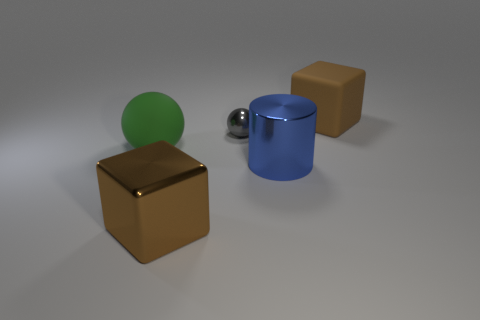Subtract all gray spheres. How many spheres are left? 1 Subtract all cylinders. How many objects are left? 4 Add 2 tiny cyan rubber objects. How many objects exist? 7 Subtract 1 balls. How many balls are left? 1 Subtract all red blocks. How many yellow balls are left? 0 Add 3 large brown cubes. How many large brown cubes exist? 5 Subtract 0 brown cylinders. How many objects are left? 5 Subtract all yellow blocks. Subtract all brown cylinders. How many blocks are left? 2 Subtract all green matte spheres. Subtract all large balls. How many objects are left? 3 Add 3 big green rubber things. How many big green rubber things are left? 4 